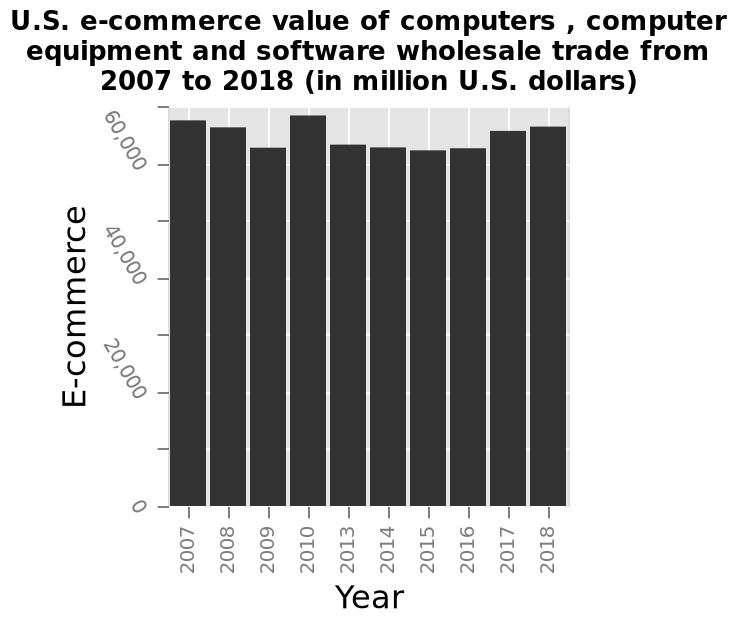<image>
Which year had the highest ecommerce value?  The year 2020 had the highest ecommerce value at about 69,000. 